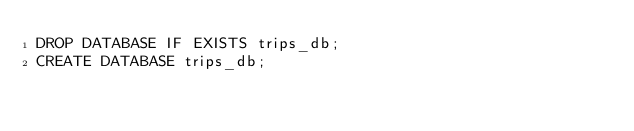<code> <loc_0><loc_0><loc_500><loc_500><_SQL_>DROP DATABASE IF EXISTS trips_db;
CREATE DATABASE trips_db;
</code> 